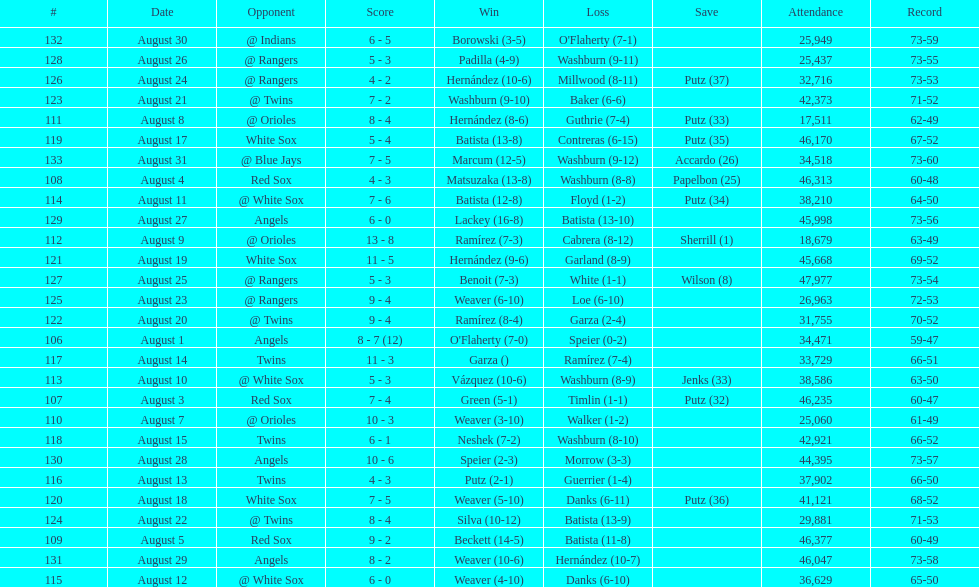How many losses during stretch? 7. 